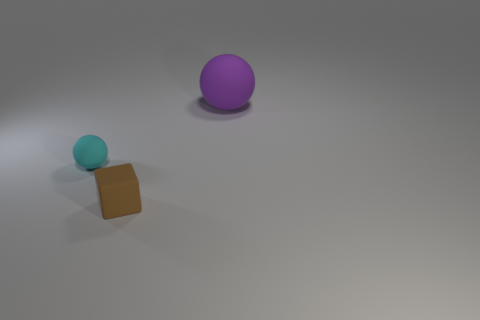There is a object that is both on the left side of the purple matte sphere and behind the rubber block; what is its size?
Ensure brevity in your answer.  Small. Is there a red object that has the same material as the brown object?
Make the answer very short. No. How many other blocks have the same color as the small matte block?
Provide a succinct answer. 0. There is a brown thing that is made of the same material as the big purple thing; what is its size?
Keep it short and to the point. Small. The thing left of the tiny rubber cube has what shape?
Your answer should be very brief. Sphere. There is a purple matte object that is the same shape as the tiny cyan thing; what is its size?
Make the answer very short. Large. What number of purple rubber objects are on the right side of the small thing right of the rubber ball to the left of the large purple thing?
Your response must be concise. 1. Are there an equal number of small matte things that are to the left of the small cube and large gray metal blocks?
Offer a very short reply. No. How many balls are either rubber objects or cyan matte things?
Provide a succinct answer. 2. Are there an equal number of small cyan rubber objects to the right of the small brown object and objects to the left of the large sphere?
Provide a succinct answer. No. 